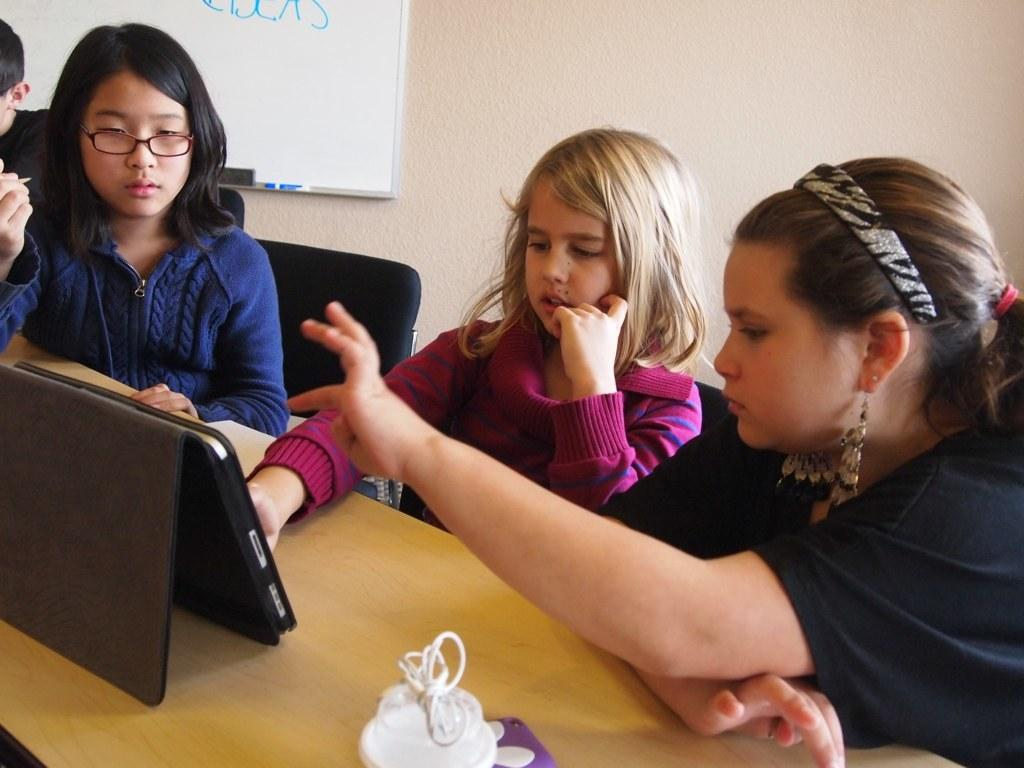How many girls are in the image? There are three girls in the image. What are the girls doing in the image? The girls are sitting on chairs. What is in front of the girls? There is a table in front of the girls. What is on the table? There is a tab and an object on the table. What can be seen on the wall in the background? There is a board on the wall in the background. How many tomatoes are on the table in the image? There are no tomatoes present in the image. What direction are the girls pointing in the image? The girls are not pointing in any direction in the image. 